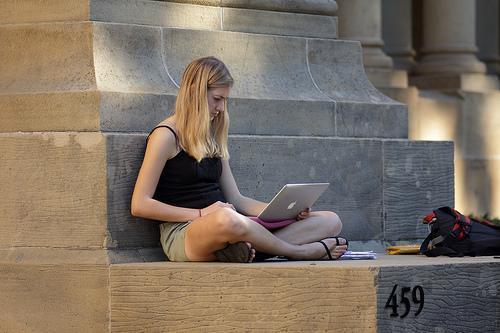How many people are in the photo?
Give a very brief answer. 1. 